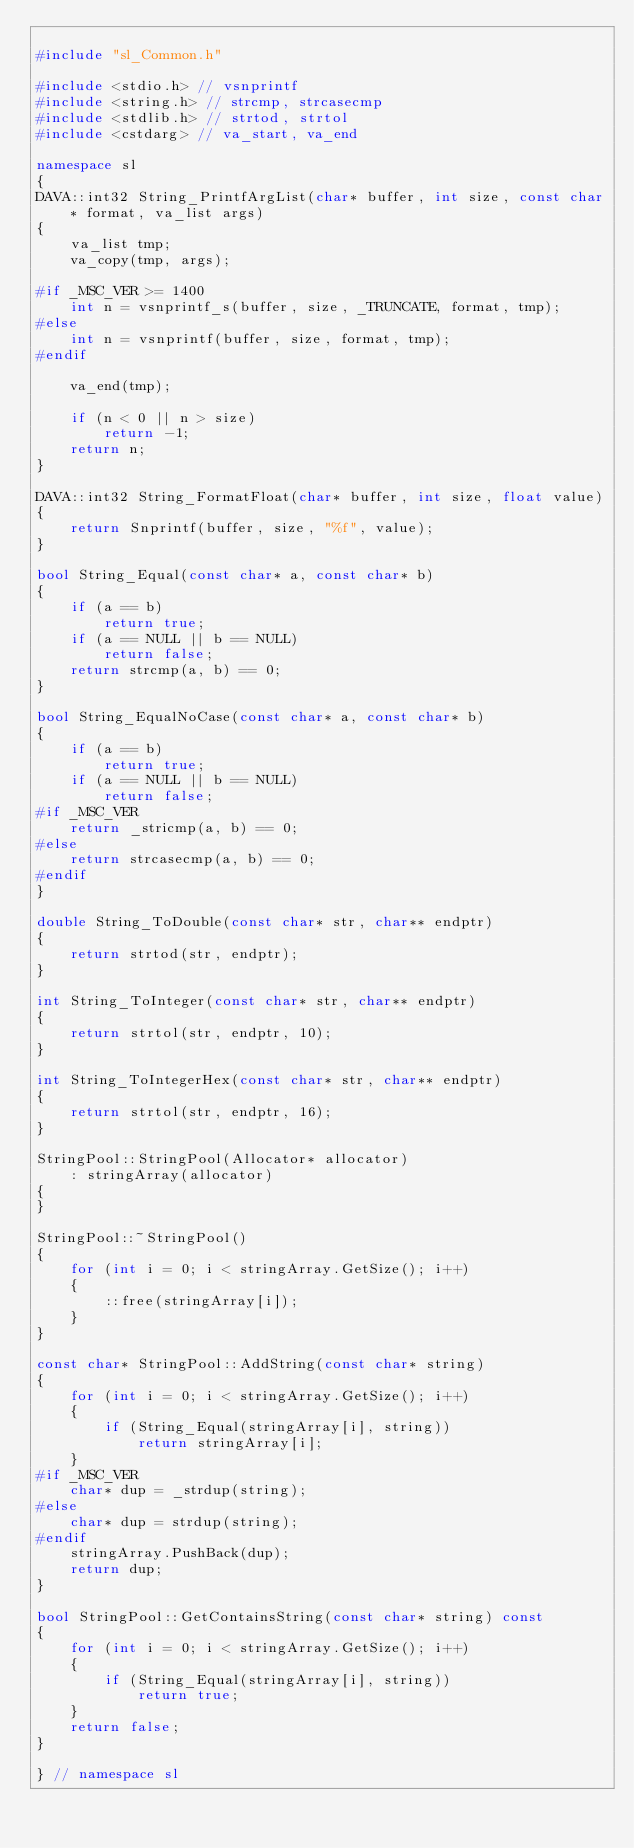Convert code to text. <code><loc_0><loc_0><loc_500><loc_500><_C++_>
#include "sl_Common.h"

#include <stdio.h> // vsnprintf
#include <string.h> // strcmp, strcasecmp
#include <stdlib.h> // strtod, strtol
#include <cstdarg> // va_start, va_end

namespace sl
{
DAVA::int32 String_PrintfArgList(char* buffer, int size, const char* format, va_list args)
{
    va_list tmp;
    va_copy(tmp, args);

#if _MSC_VER >= 1400
    int n = vsnprintf_s(buffer, size, _TRUNCATE, format, tmp);
#else
    int n = vsnprintf(buffer, size, format, tmp);
#endif

    va_end(tmp);

    if (n < 0 || n > size)
        return -1;
    return n;
}

DAVA::int32 String_FormatFloat(char* buffer, int size, float value)
{
    return Snprintf(buffer, size, "%f", value);
}

bool String_Equal(const char* a, const char* b)
{
    if (a == b)
        return true;
    if (a == NULL || b == NULL)
        return false;
    return strcmp(a, b) == 0;
}

bool String_EqualNoCase(const char* a, const char* b)
{
    if (a == b)
        return true;
    if (a == NULL || b == NULL)
        return false;
#if _MSC_VER
    return _stricmp(a, b) == 0;
#else
    return strcasecmp(a, b) == 0;
#endif
}

double String_ToDouble(const char* str, char** endptr)
{
    return strtod(str, endptr);
}

int String_ToInteger(const char* str, char** endptr)
{
    return strtol(str, endptr, 10);
}

int String_ToIntegerHex(const char* str, char** endptr)
{
    return strtol(str, endptr, 16);
}

StringPool::StringPool(Allocator* allocator)
    : stringArray(allocator)
{
}

StringPool::~StringPool()
{
    for (int i = 0; i < stringArray.GetSize(); i++)
    {
        ::free(stringArray[i]);
    }
}

const char* StringPool::AddString(const char* string)
{
    for (int i = 0; i < stringArray.GetSize(); i++)
    {
        if (String_Equal(stringArray[i], string))
            return stringArray[i];
    }
#if _MSC_VER
    char* dup = _strdup(string);
#else
    char* dup = strdup(string);
#endif
    stringArray.PushBack(dup);
    return dup;
}

bool StringPool::GetContainsString(const char* string) const
{
    for (int i = 0; i < stringArray.GetSize(); i++)
    {
        if (String_Equal(stringArray[i], string))
            return true;
    }
    return false;
}

} // namespace sl
</code> 